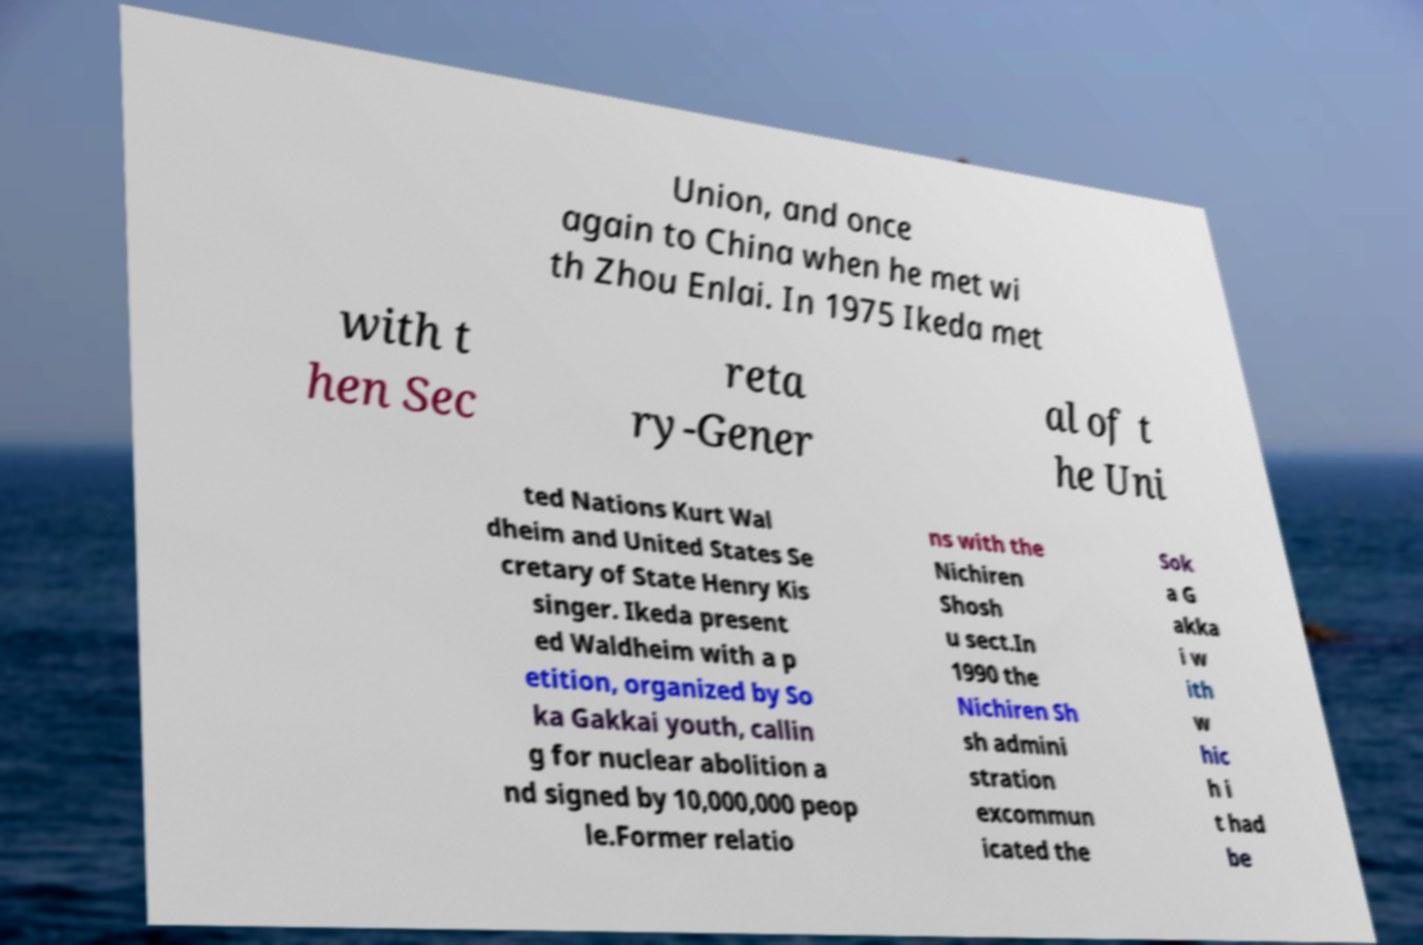There's text embedded in this image that I need extracted. Can you transcribe it verbatim? Union, and once again to China when he met wi th Zhou Enlai. In 1975 Ikeda met with t hen Sec reta ry-Gener al of t he Uni ted Nations Kurt Wal dheim and United States Se cretary of State Henry Kis singer. Ikeda present ed Waldheim with a p etition, organized by So ka Gakkai youth, callin g for nuclear abolition a nd signed by 10,000,000 peop le.Former relatio ns with the Nichiren Shosh u sect.In 1990 the Nichiren Sh sh admini stration excommun icated the Sok a G akka i w ith w hic h i t had be 